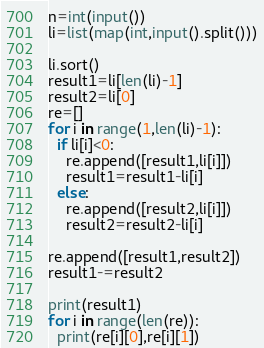Convert code to text. <code><loc_0><loc_0><loc_500><loc_500><_Python_>n=int(input())
li=list(map(int,input().split()))

li.sort()
result1=li[len(li)-1]
result2=li[0]
re=[]
for i in range(1,len(li)-1):
  if li[i]<0:
    re.append([result1,li[i]])
    result1=result1-li[i]
  else:
    re.append([result2,li[i]])
    result2=result2-li[i]
               
re.append([result1,result2])
result1-=result2

print(result1)
for i in range(len(re)):
  print(re[i][0],re[i][1])</code> 